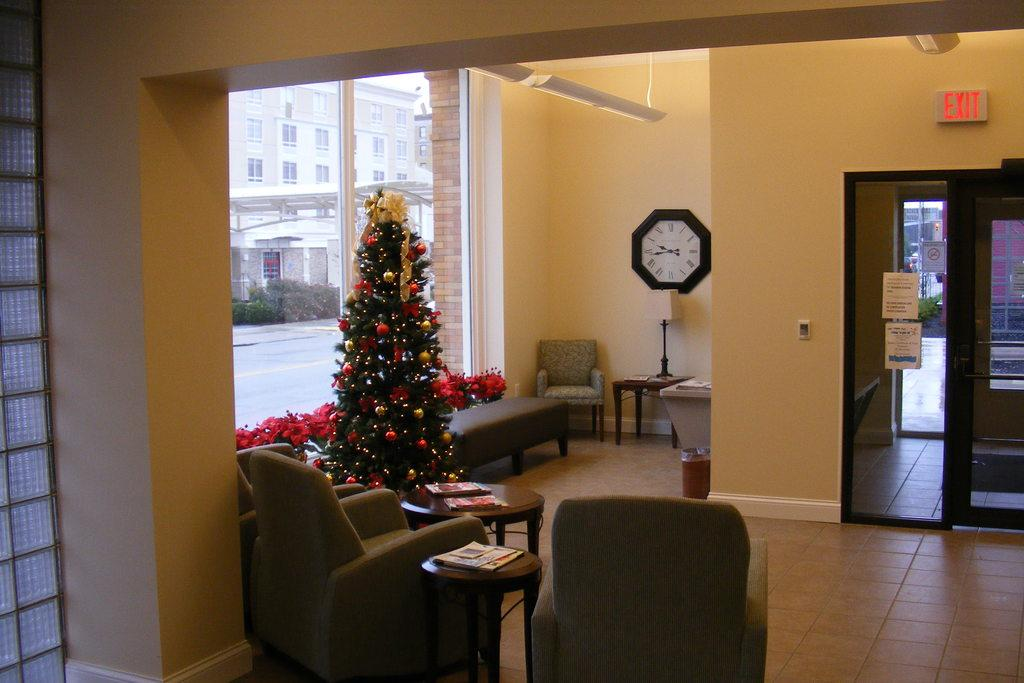What type of furniture is present in the image? There are chairs in the image. What holiday decoration can be seen in the image? There is a Christmas tree in the image. What time-telling device is on the wall in the image? There is a clock on the wall in the image. What type of lighting is present on a table in the image? There is a lamp on a table in the image. Where is the list of items stored in the image? There is no list of items present in the image. What type of storage compartment is available for holding items in the image? There is no drawer or pocket visible in the image. 